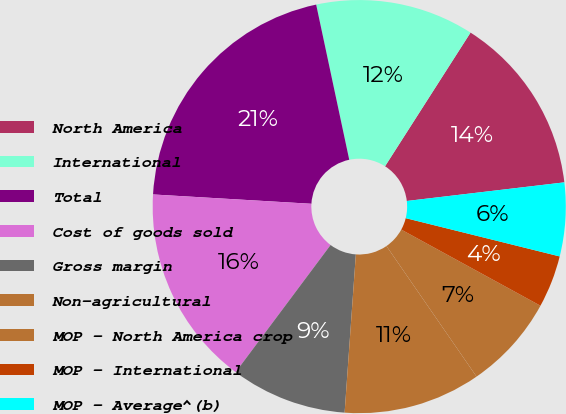<chart> <loc_0><loc_0><loc_500><loc_500><pie_chart><fcel>North America<fcel>International<fcel>Total<fcel>Cost of goods sold<fcel>Gross margin<fcel>Non-agricultural<fcel>MOP - North America crop<fcel>MOP - International<fcel>MOP - Average^(b)<nl><fcel>14.07%<fcel>12.4%<fcel>20.72%<fcel>15.73%<fcel>9.08%<fcel>10.74%<fcel>7.42%<fcel>4.09%<fcel>5.75%<nl></chart> 